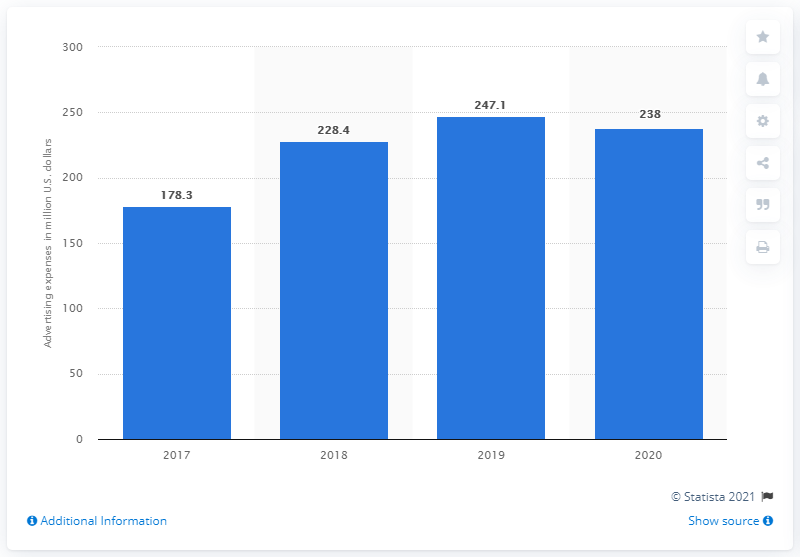Mention a couple of crucial points in this snapshot. In the fiscal year 2020, Tapestry spent $238 million on advertising. The advertising expenditure of Tapestry, Inc. in 2017 was $178.3 million. 